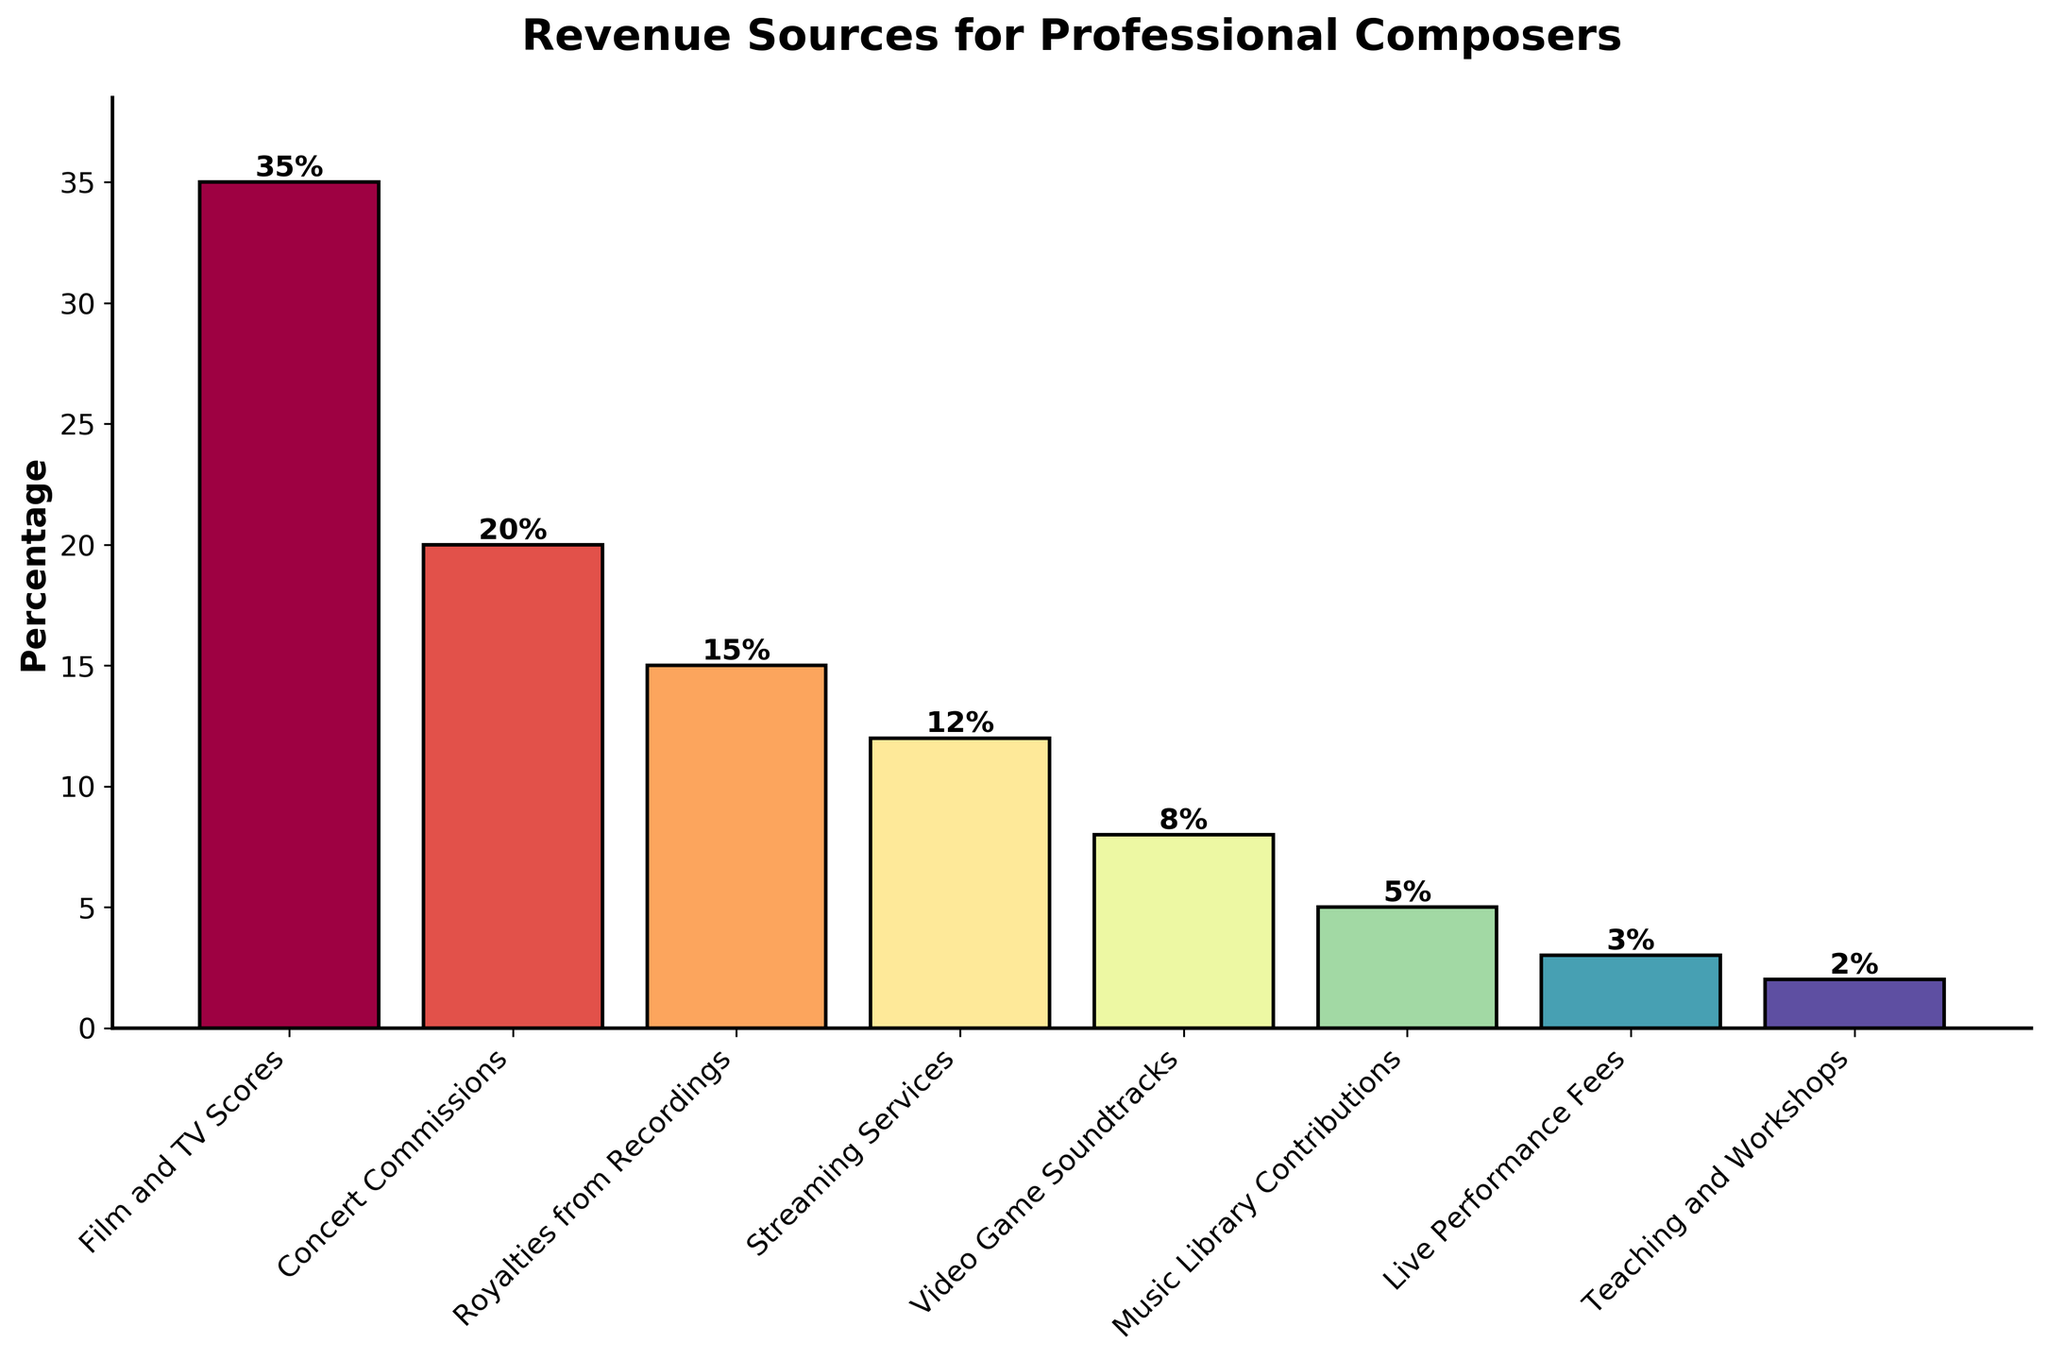Which revenue source contributes the most to professional composers' income? Look at the height of the bars in the figure. The tallest bar represents the revenue source contributing the most, which is Film and TV Scores.
Answer: Film and TV Scores What is the combined percentage of revenue from Royalties from Recordings and Streaming Services? Add the percentages of Royalties from Recordings (15%) and Streaming Services (12%). 15% + 12% = 27%
Answer: 27% How does the percentage of Live Performance Fees compare to Teaching and Workshops? Compare the heights of the bars for Live Performance Fees (3%) and Teaching and Workshops (2%). Since 3% > 2%, Live Performance Fees are higher.
Answer: Live Performance Fees are higher Which revenue sources account for less than 10% of the total revenue? Identify the bars whose heights are less than 10%. These are Video Game Soundtracks (8%), Music Library Contributions (5%), Live Performance Fees (3%), and Teaching and Workshops (2%).
Answer: Video Game Soundtracks, Music Library Contributions, Live Performance Fees, Teaching and Workshops What is the total percentage of revenue accounted for by the top two revenue sources? Add the percentages of Film and TV Scores (35%) and Concert Commissions (20%). 35% + 20% = 55%
Answer: 55% Is the percentage of revenue from Music Library Contributions greater than the percentage from Teaching and Workshops? Compare the heights of the bars for Music Library Contributions (5%) and Teaching and Workshops (2%). 5% > 2%
Answer: Yes What is the difference between the highest and the lowest revenue source percentages? Subtract the lowest percentage (Teaching and Workshops, 2%) from the highest percentage (Film and TV Scores, 35%). 35% - 2% = 33%
Answer: 33% Which revenue source has the second lowest percentage? Identify the bars and their heights; the second lowest is Live Performance Fees at 3%, just above Teaching and Workshops at 2%.
Answer: Live Performance Fees 